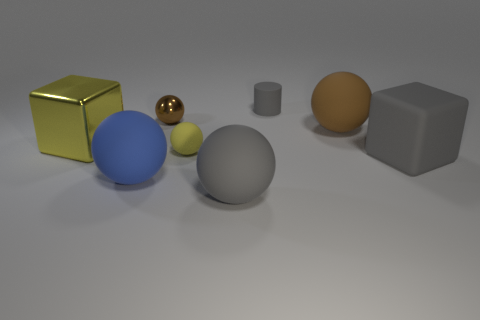What is the small ball behind the big yellow metal object made of?
Your answer should be compact. Metal. The metallic block has what color?
Your answer should be very brief. Yellow. Does the blue object that is left of the matte cube have the same size as the small yellow thing?
Your answer should be very brief. No. What is the material of the yellow object that is in front of the block that is behind the gray matte object that is on the right side of the small gray cylinder?
Your answer should be compact. Rubber. There is a big sphere to the right of the tiny gray cylinder; is its color the same as the large block to the right of the brown rubber ball?
Keep it short and to the point. No. There is a big ball behind the gray thing on the right side of the small gray matte object; what is its material?
Provide a short and direct response. Rubber. The sphere that is the same size as the yellow rubber thing is what color?
Give a very brief answer. Brown. There is a small yellow matte thing; is its shape the same as the gray matte object that is left of the tiny cylinder?
Ensure brevity in your answer.  Yes. There is a big rubber thing that is the same color as the big rubber cube; what shape is it?
Provide a succinct answer. Sphere. What number of tiny cylinders are in front of the large gray object in front of the large gray matte thing that is to the right of the large brown matte object?
Your response must be concise. 0. 